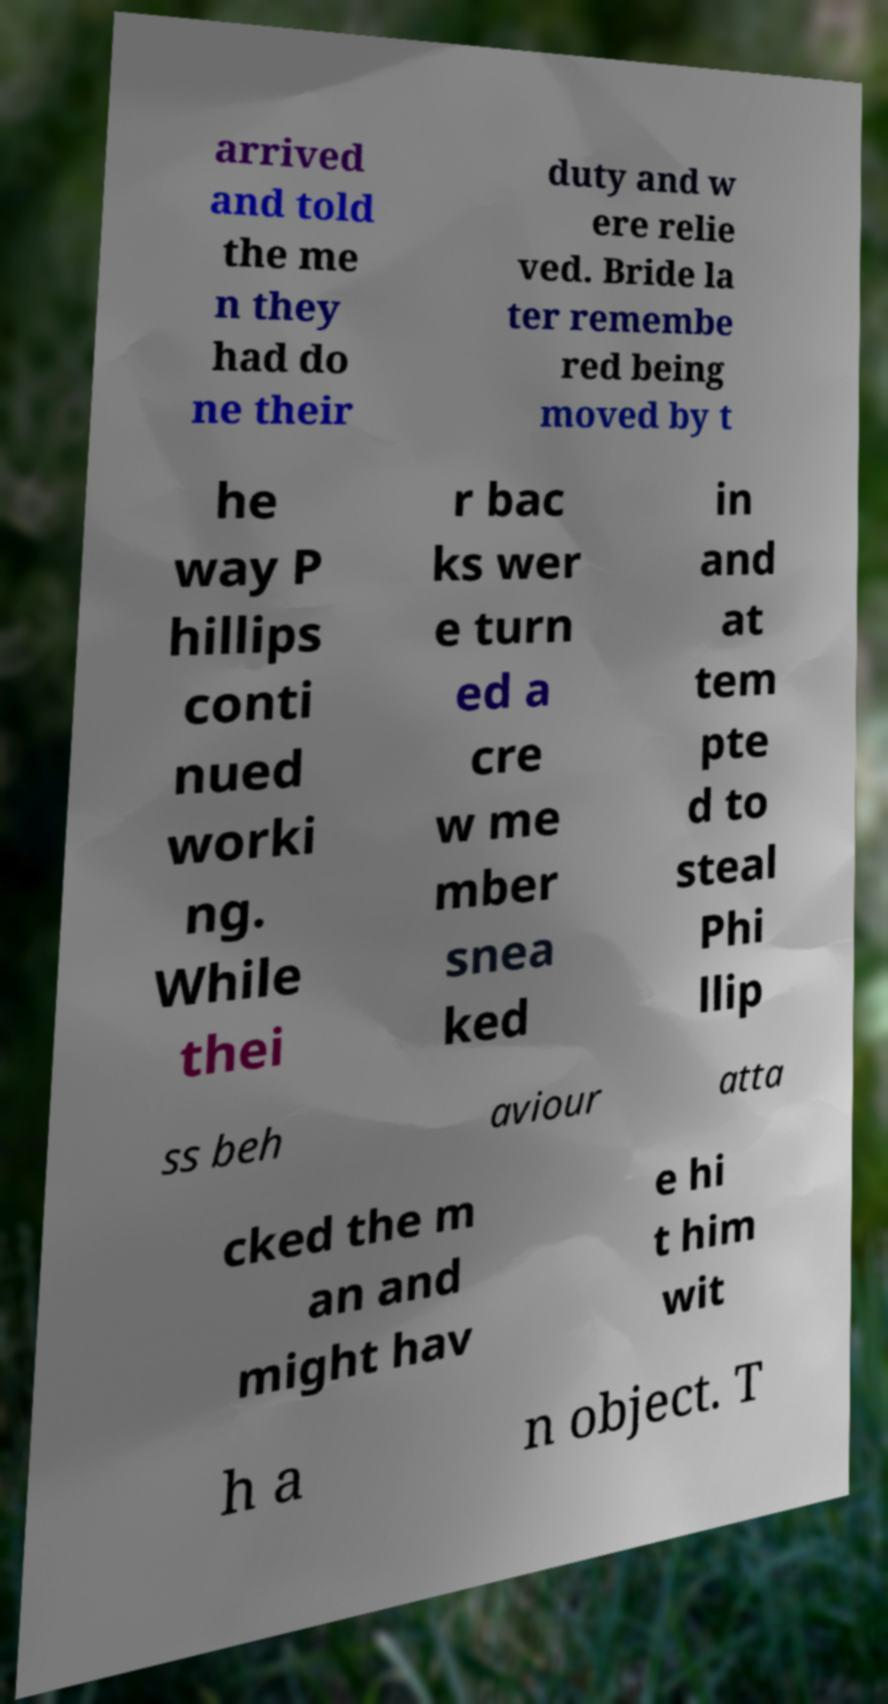For documentation purposes, I need the text within this image transcribed. Could you provide that? arrived and told the me n they had do ne their duty and w ere relie ved. Bride la ter remembe red being moved by t he way P hillips conti nued worki ng. While thei r bac ks wer e turn ed a cre w me mber snea ked in and at tem pte d to steal Phi llip ss beh aviour atta cked the m an and might hav e hi t him wit h a n object. T 